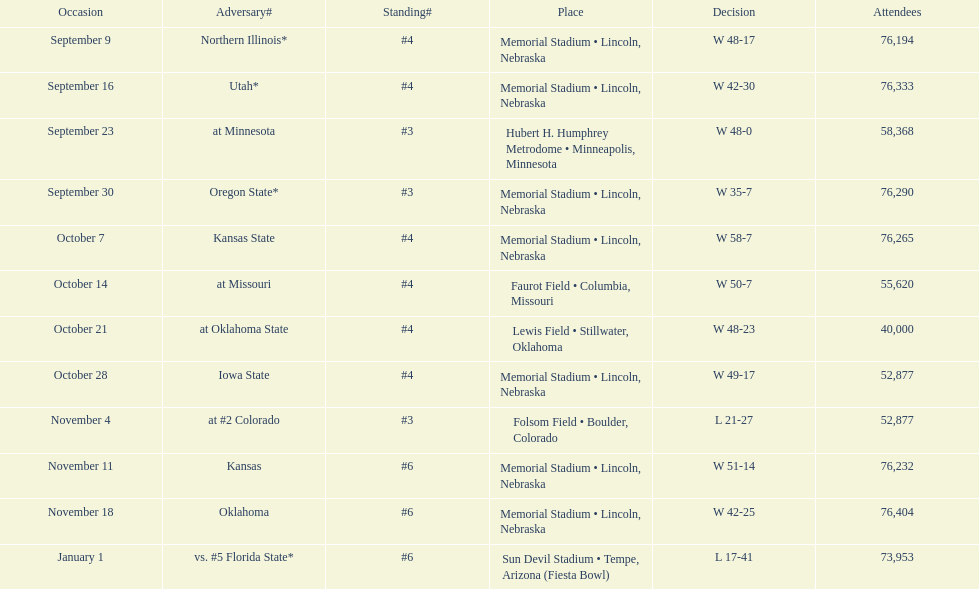How many games was their ranking not lower than #5? 9. 